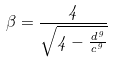Convert formula to latex. <formula><loc_0><loc_0><loc_500><loc_500>\beta = \frac { 4 } { \sqrt { 4 - \frac { d ^ { 9 } } { c ^ { 9 } } } }</formula> 